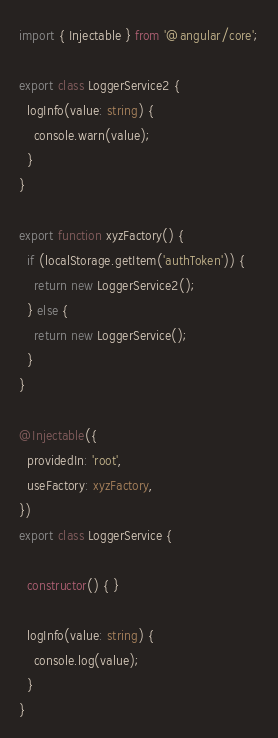Convert code to text. <code><loc_0><loc_0><loc_500><loc_500><_TypeScript_>import { Injectable } from '@angular/core';

export class LoggerService2 {
  logInfo(value: string) {
    console.warn(value);
  }
}

export function xyzFactory() {
  if (localStorage.getItem('authToken')) {
    return new LoggerService2();
  } else {
    return new LoggerService();
  }
}

@Injectable({
  providedIn: 'root',
  useFactory: xyzFactory,
})
export class LoggerService {

  constructor() { }

  logInfo(value: string) {
    console.log(value);
  }
}
</code> 